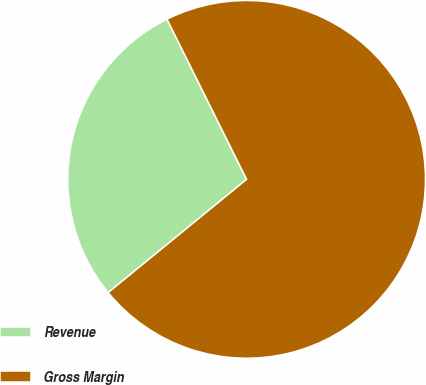Convert chart to OTSL. <chart><loc_0><loc_0><loc_500><loc_500><pie_chart><fcel>Revenue<fcel>Gross Margin<nl><fcel>28.57%<fcel>71.43%<nl></chart> 